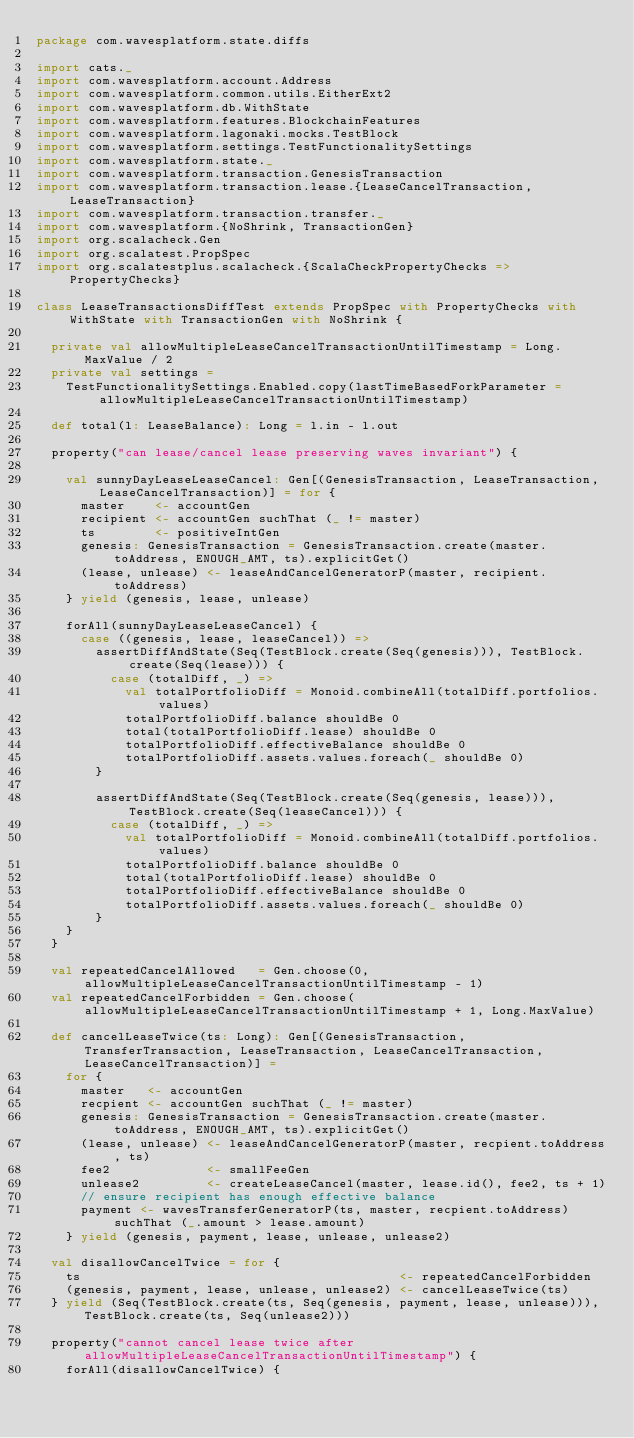Convert code to text. <code><loc_0><loc_0><loc_500><loc_500><_Scala_>package com.wavesplatform.state.diffs

import cats._
import com.wavesplatform.account.Address
import com.wavesplatform.common.utils.EitherExt2
import com.wavesplatform.db.WithState
import com.wavesplatform.features.BlockchainFeatures
import com.wavesplatform.lagonaki.mocks.TestBlock
import com.wavesplatform.settings.TestFunctionalitySettings
import com.wavesplatform.state._
import com.wavesplatform.transaction.GenesisTransaction
import com.wavesplatform.transaction.lease.{LeaseCancelTransaction, LeaseTransaction}
import com.wavesplatform.transaction.transfer._
import com.wavesplatform.{NoShrink, TransactionGen}
import org.scalacheck.Gen
import org.scalatest.PropSpec
import org.scalatestplus.scalacheck.{ScalaCheckPropertyChecks => PropertyChecks}

class LeaseTransactionsDiffTest extends PropSpec with PropertyChecks with WithState with TransactionGen with NoShrink {

  private val allowMultipleLeaseCancelTransactionUntilTimestamp = Long.MaxValue / 2
  private val settings =
    TestFunctionalitySettings.Enabled.copy(lastTimeBasedForkParameter = allowMultipleLeaseCancelTransactionUntilTimestamp)

  def total(l: LeaseBalance): Long = l.in - l.out

  property("can lease/cancel lease preserving waves invariant") {

    val sunnyDayLeaseLeaseCancel: Gen[(GenesisTransaction, LeaseTransaction, LeaseCancelTransaction)] = for {
      master    <- accountGen
      recipient <- accountGen suchThat (_ != master)
      ts        <- positiveIntGen
      genesis: GenesisTransaction = GenesisTransaction.create(master.toAddress, ENOUGH_AMT, ts).explicitGet()
      (lease, unlease) <- leaseAndCancelGeneratorP(master, recipient.toAddress)
    } yield (genesis, lease, unlease)

    forAll(sunnyDayLeaseLeaseCancel) {
      case ((genesis, lease, leaseCancel)) =>
        assertDiffAndState(Seq(TestBlock.create(Seq(genesis))), TestBlock.create(Seq(lease))) {
          case (totalDiff, _) =>
            val totalPortfolioDiff = Monoid.combineAll(totalDiff.portfolios.values)
            totalPortfolioDiff.balance shouldBe 0
            total(totalPortfolioDiff.lease) shouldBe 0
            totalPortfolioDiff.effectiveBalance shouldBe 0
            totalPortfolioDiff.assets.values.foreach(_ shouldBe 0)
        }

        assertDiffAndState(Seq(TestBlock.create(Seq(genesis, lease))), TestBlock.create(Seq(leaseCancel))) {
          case (totalDiff, _) =>
            val totalPortfolioDiff = Monoid.combineAll(totalDiff.portfolios.values)
            totalPortfolioDiff.balance shouldBe 0
            total(totalPortfolioDiff.lease) shouldBe 0
            totalPortfolioDiff.effectiveBalance shouldBe 0
            totalPortfolioDiff.assets.values.foreach(_ shouldBe 0)
        }
    }
  }

  val repeatedCancelAllowed   = Gen.choose(0, allowMultipleLeaseCancelTransactionUntilTimestamp - 1)
  val repeatedCancelForbidden = Gen.choose(allowMultipleLeaseCancelTransactionUntilTimestamp + 1, Long.MaxValue)

  def cancelLeaseTwice(ts: Long): Gen[(GenesisTransaction, TransferTransaction, LeaseTransaction, LeaseCancelTransaction, LeaseCancelTransaction)] =
    for {
      master   <- accountGen
      recpient <- accountGen suchThat (_ != master)
      genesis: GenesisTransaction = GenesisTransaction.create(master.toAddress, ENOUGH_AMT, ts).explicitGet()
      (lease, unlease) <- leaseAndCancelGeneratorP(master, recpient.toAddress, ts)
      fee2             <- smallFeeGen
      unlease2         <- createLeaseCancel(master, lease.id(), fee2, ts + 1)
      // ensure recipient has enough effective balance
      payment <- wavesTransferGeneratorP(ts, master, recpient.toAddress) suchThat (_.amount > lease.amount)
    } yield (genesis, payment, lease, unlease, unlease2)

  val disallowCancelTwice = for {
    ts                                           <- repeatedCancelForbidden
    (genesis, payment, lease, unlease, unlease2) <- cancelLeaseTwice(ts)
  } yield (Seq(TestBlock.create(ts, Seq(genesis, payment, lease, unlease))), TestBlock.create(ts, Seq(unlease2)))

  property("cannot cancel lease twice after allowMultipleLeaseCancelTransactionUntilTimestamp") {
    forAll(disallowCancelTwice) {</code> 